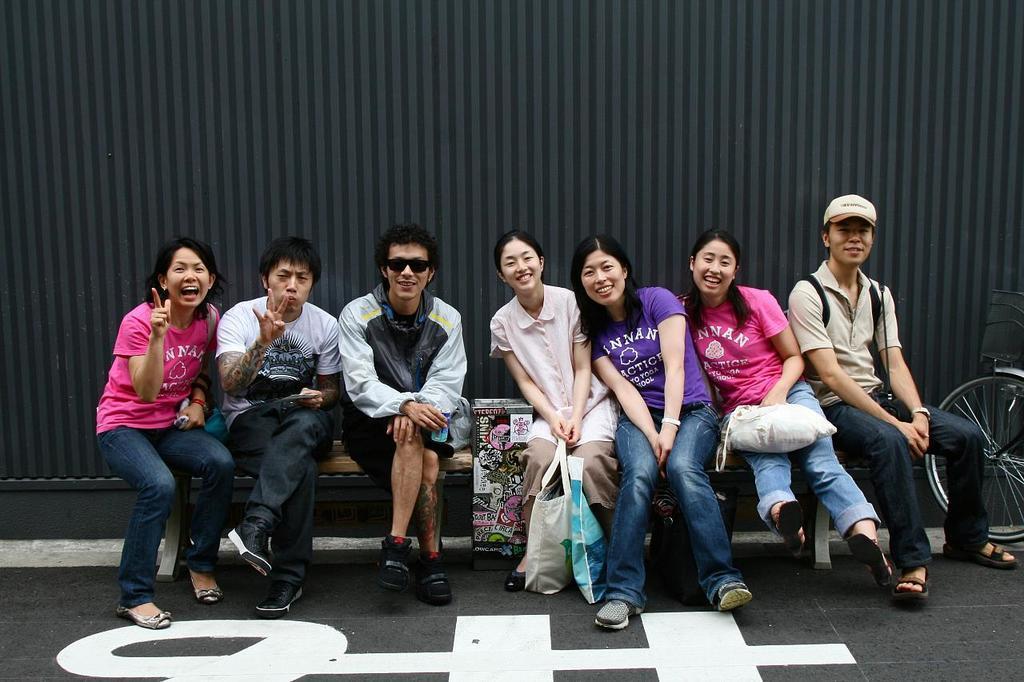In one or two sentences, can you explain what this image depicts? In this image we can see a group of people sitting on the bench. one woman is holding bags with her hands. To the right side of the image we can see a bicycle placed on the ground. In the background, we can see the wall. 